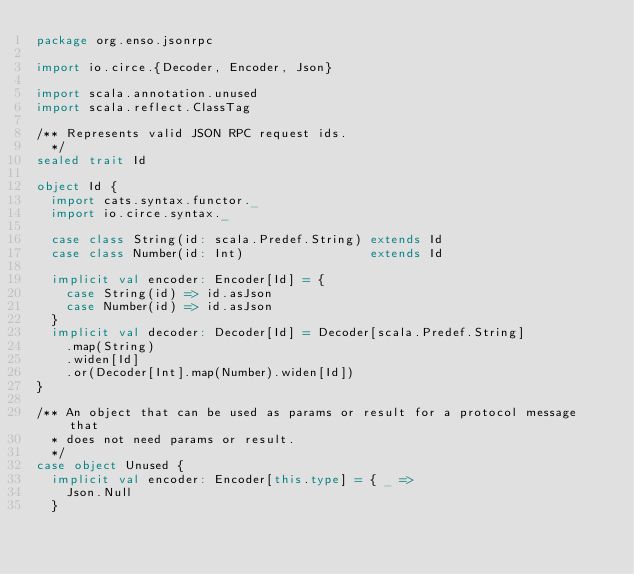<code> <loc_0><loc_0><loc_500><loc_500><_Scala_>package org.enso.jsonrpc

import io.circe.{Decoder, Encoder, Json}

import scala.annotation.unused
import scala.reflect.ClassTag

/** Represents valid JSON RPC request ids.
  */
sealed trait Id

object Id {
  import cats.syntax.functor._
  import io.circe.syntax._

  case class String(id: scala.Predef.String) extends Id
  case class Number(id: Int)                 extends Id

  implicit val encoder: Encoder[Id] = {
    case String(id) => id.asJson
    case Number(id) => id.asJson
  }
  implicit val decoder: Decoder[Id] = Decoder[scala.Predef.String]
    .map(String)
    .widen[Id]
    .or(Decoder[Int].map(Number).widen[Id])
}

/** An object that can be used as params or result for a protocol message that
  * does not need params or result.
  */
case object Unused {
  implicit val encoder: Encoder[this.type] = { _ =>
    Json.Null
  }</code> 